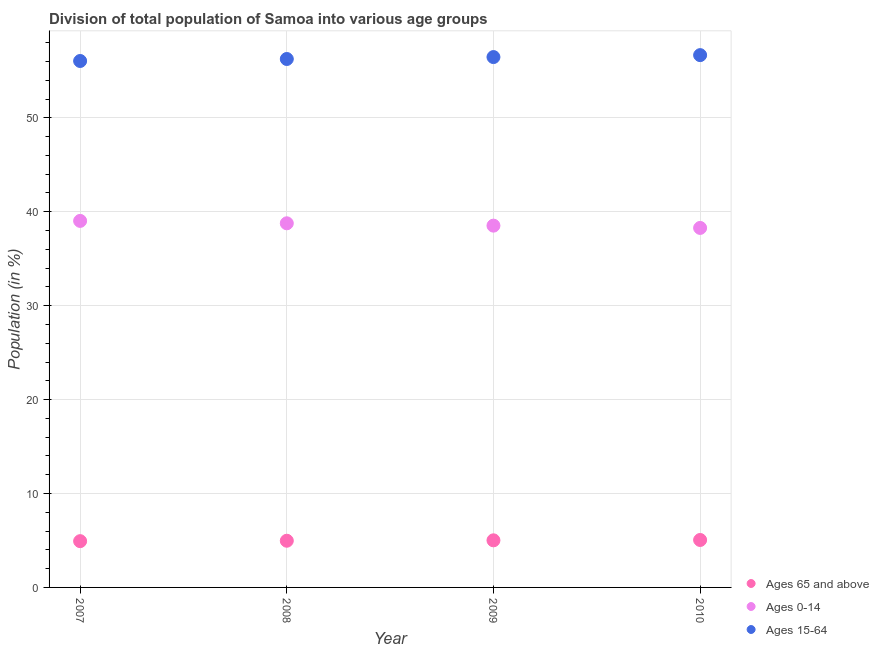How many different coloured dotlines are there?
Your answer should be compact. 3. Is the number of dotlines equal to the number of legend labels?
Keep it short and to the point. Yes. What is the percentage of population within the age-group of 65 and above in 2009?
Offer a terse response. 5.01. Across all years, what is the maximum percentage of population within the age-group 15-64?
Provide a succinct answer. 56.67. Across all years, what is the minimum percentage of population within the age-group of 65 and above?
Keep it short and to the point. 4.93. In which year was the percentage of population within the age-group 15-64 minimum?
Keep it short and to the point. 2007. What is the total percentage of population within the age-group 15-64 in the graph?
Give a very brief answer. 225.45. What is the difference between the percentage of population within the age-group 0-14 in 2008 and that in 2010?
Your answer should be very brief. 0.49. What is the difference between the percentage of population within the age-group of 65 and above in 2007 and the percentage of population within the age-group 0-14 in 2010?
Keep it short and to the point. -33.35. What is the average percentage of population within the age-group of 65 and above per year?
Your response must be concise. 4.99. In the year 2009, what is the difference between the percentage of population within the age-group 15-64 and percentage of population within the age-group 0-14?
Offer a terse response. 17.95. What is the ratio of the percentage of population within the age-group 0-14 in 2007 to that in 2010?
Provide a short and direct response. 1.02. What is the difference between the highest and the second highest percentage of population within the age-group 15-64?
Offer a very short reply. 0.21. What is the difference between the highest and the lowest percentage of population within the age-group 0-14?
Offer a terse response. 0.75. Is the sum of the percentage of population within the age-group of 65 and above in 2007 and 2008 greater than the maximum percentage of population within the age-group 0-14 across all years?
Ensure brevity in your answer.  No. Does the percentage of population within the age-group of 65 and above monotonically increase over the years?
Your response must be concise. Yes. How many dotlines are there?
Provide a short and direct response. 3. How many years are there in the graph?
Keep it short and to the point. 4. Does the graph contain any zero values?
Offer a very short reply. No. Where does the legend appear in the graph?
Provide a short and direct response. Bottom right. How many legend labels are there?
Provide a succinct answer. 3. What is the title of the graph?
Your response must be concise. Division of total population of Samoa into various age groups
. What is the label or title of the X-axis?
Your answer should be compact. Year. What is the Population (in %) of Ages 65 and above in 2007?
Provide a succinct answer. 4.93. What is the Population (in %) of Ages 0-14 in 2007?
Your answer should be very brief. 39.02. What is the Population (in %) in Ages 15-64 in 2007?
Keep it short and to the point. 56.05. What is the Population (in %) of Ages 65 and above in 2008?
Make the answer very short. 4.97. What is the Population (in %) in Ages 0-14 in 2008?
Offer a very short reply. 38.77. What is the Population (in %) of Ages 15-64 in 2008?
Provide a succinct answer. 56.26. What is the Population (in %) of Ages 65 and above in 2009?
Provide a succinct answer. 5.01. What is the Population (in %) in Ages 0-14 in 2009?
Keep it short and to the point. 38.52. What is the Population (in %) in Ages 15-64 in 2009?
Make the answer very short. 56.47. What is the Population (in %) of Ages 65 and above in 2010?
Keep it short and to the point. 5.05. What is the Population (in %) of Ages 0-14 in 2010?
Make the answer very short. 38.28. What is the Population (in %) in Ages 15-64 in 2010?
Provide a succinct answer. 56.67. Across all years, what is the maximum Population (in %) of Ages 65 and above?
Keep it short and to the point. 5.05. Across all years, what is the maximum Population (in %) of Ages 0-14?
Offer a terse response. 39.02. Across all years, what is the maximum Population (in %) in Ages 15-64?
Keep it short and to the point. 56.67. Across all years, what is the minimum Population (in %) of Ages 65 and above?
Offer a very short reply. 4.93. Across all years, what is the minimum Population (in %) in Ages 0-14?
Your answer should be very brief. 38.28. Across all years, what is the minimum Population (in %) in Ages 15-64?
Offer a terse response. 56.05. What is the total Population (in %) in Ages 65 and above in the graph?
Your answer should be very brief. 19.96. What is the total Population (in %) in Ages 0-14 in the graph?
Offer a terse response. 154.59. What is the total Population (in %) of Ages 15-64 in the graph?
Offer a very short reply. 225.45. What is the difference between the Population (in %) in Ages 65 and above in 2007 and that in 2008?
Provide a succinct answer. -0.04. What is the difference between the Population (in %) of Ages 0-14 in 2007 and that in 2008?
Give a very brief answer. 0.26. What is the difference between the Population (in %) of Ages 15-64 in 2007 and that in 2008?
Keep it short and to the point. -0.21. What is the difference between the Population (in %) of Ages 65 and above in 2007 and that in 2009?
Keep it short and to the point. -0.09. What is the difference between the Population (in %) of Ages 0-14 in 2007 and that in 2009?
Your answer should be very brief. 0.51. What is the difference between the Population (in %) in Ages 15-64 in 2007 and that in 2009?
Offer a terse response. -0.42. What is the difference between the Population (in %) of Ages 65 and above in 2007 and that in 2010?
Offer a very short reply. -0.12. What is the difference between the Population (in %) in Ages 0-14 in 2007 and that in 2010?
Ensure brevity in your answer.  0.75. What is the difference between the Population (in %) of Ages 15-64 in 2007 and that in 2010?
Ensure brevity in your answer.  -0.62. What is the difference between the Population (in %) in Ages 65 and above in 2008 and that in 2009?
Provide a succinct answer. -0.04. What is the difference between the Population (in %) in Ages 0-14 in 2008 and that in 2009?
Make the answer very short. 0.25. What is the difference between the Population (in %) in Ages 15-64 in 2008 and that in 2009?
Your answer should be compact. -0.21. What is the difference between the Population (in %) in Ages 65 and above in 2008 and that in 2010?
Provide a short and direct response. -0.08. What is the difference between the Population (in %) in Ages 0-14 in 2008 and that in 2010?
Make the answer very short. 0.49. What is the difference between the Population (in %) in Ages 15-64 in 2008 and that in 2010?
Your answer should be very brief. -0.41. What is the difference between the Population (in %) in Ages 65 and above in 2009 and that in 2010?
Keep it short and to the point. -0.04. What is the difference between the Population (in %) in Ages 0-14 in 2009 and that in 2010?
Provide a succinct answer. 0.24. What is the difference between the Population (in %) in Ages 15-64 in 2009 and that in 2010?
Your answer should be very brief. -0.21. What is the difference between the Population (in %) of Ages 65 and above in 2007 and the Population (in %) of Ages 0-14 in 2008?
Make the answer very short. -33.84. What is the difference between the Population (in %) in Ages 65 and above in 2007 and the Population (in %) in Ages 15-64 in 2008?
Your answer should be very brief. -51.33. What is the difference between the Population (in %) of Ages 0-14 in 2007 and the Population (in %) of Ages 15-64 in 2008?
Offer a very short reply. -17.24. What is the difference between the Population (in %) in Ages 65 and above in 2007 and the Population (in %) in Ages 0-14 in 2009?
Your response must be concise. -33.59. What is the difference between the Population (in %) in Ages 65 and above in 2007 and the Population (in %) in Ages 15-64 in 2009?
Your response must be concise. -51.54. What is the difference between the Population (in %) of Ages 0-14 in 2007 and the Population (in %) of Ages 15-64 in 2009?
Ensure brevity in your answer.  -17.44. What is the difference between the Population (in %) of Ages 65 and above in 2007 and the Population (in %) of Ages 0-14 in 2010?
Ensure brevity in your answer.  -33.35. What is the difference between the Population (in %) of Ages 65 and above in 2007 and the Population (in %) of Ages 15-64 in 2010?
Ensure brevity in your answer.  -51.75. What is the difference between the Population (in %) of Ages 0-14 in 2007 and the Population (in %) of Ages 15-64 in 2010?
Ensure brevity in your answer.  -17.65. What is the difference between the Population (in %) in Ages 65 and above in 2008 and the Population (in %) in Ages 0-14 in 2009?
Give a very brief answer. -33.55. What is the difference between the Population (in %) of Ages 65 and above in 2008 and the Population (in %) of Ages 15-64 in 2009?
Keep it short and to the point. -51.5. What is the difference between the Population (in %) in Ages 0-14 in 2008 and the Population (in %) in Ages 15-64 in 2009?
Ensure brevity in your answer.  -17.7. What is the difference between the Population (in %) in Ages 65 and above in 2008 and the Population (in %) in Ages 0-14 in 2010?
Make the answer very short. -33.3. What is the difference between the Population (in %) in Ages 65 and above in 2008 and the Population (in %) in Ages 15-64 in 2010?
Make the answer very short. -51.7. What is the difference between the Population (in %) in Ages 0-14 in 2008 and the Population (in %) in Ages 15-64 in 2010?
Offer a terse response. -17.91. What is the difference between the Population (in %) in Ages 65 and above in 2009 and the Population (in %) in Ages 0-14 in 2010?
Provide a succinct answer. -33.26. What is the difference between the Population (in %) in Ages 65 and above in 2009 and the Population (in %) in Ages 15-64 in 2010?
Keep it short and to the point. -51.66. What is the difference between the Population (in %) in Ages 0-14 in 2009 and the Population (in %) in Ages 15-64 in 2010?
Ensure brevity in your answer.  -18.15. What is the average Population (in %) in Ages 65 and above per year?
Your response must be concise. 4.99. What is the average Population (in %) of Ages 0-14 per year?
Your response must be concise. 38.65. What is the average Population (in %) in Ages 15-64 per year?
Provide a short and direct response. 56.36. In the year 2007, what is the difference between the Population (in %) of Ages 65 and above and Population (in %) of Ages 0-14?
Your response must be concise. -34.1. In the year 2007, what is the difference between the Population (in %) in Ages 65 and above and Population (in %) in Ages 15-64?
Provide a short and direct response. -51.12. In the year 2007, what is the difference between the Population (in %) in Ages 0-14 and Population (in %) in Ages 15-64?
Your response must be concise. -17.02. In the year 2008, what is the difference between the Population (in %) in Ages 65 and above and Population (in %) in Ages 0-14?
Provide a succinct answer. -33.8. In the year 2008, what is the difference between the Population (in %) of Ages 65 and above and Population (in %) of Ages 15-64?
Make the answer very short. -51.29. In the year 2008, what is the difference between the Population (in %) in Ages 0-14 and Population (in %) in Ages 15-64?
Offer a very short reply. -17.49. In the year 2009, what is the difference between the Population (in %) of Ages 65 and above and Population (in %) of Ages 0-14?
Your answer should be compact. -33.5. In the year 2009, what is the difference between the Population (in %) in Ages 65 and above and Population (in %) in Ages 15-64?
Make the answer very short. -51.45. In the year 2009, what is the difference between the Population (in %) in Ages 0-14 and Population (in %) in Ages 15-64?
Offer a terse response. -17.95. In the year 2010, what is the difference between the Population (in %) in Ages 65 and above and Population (in %) in Ages 0-14?
Ensure brevity in your answer.  -33.22. In the year 2010, what is the difference between the Population (in %) of Ages 65 and above and Population (in %) of Ages 15-64?
Your answer should be compact. -51.62. In the year 2010, what is the difference between the Population (in %) of Ages 0-14 and Population (in %) of Ages 15-64?
Offer a very short reply. -18.4. What is the ratio of the Population (in %) of Ages 65 and above in 2007 to that in 2008?
Your response must be concise. 0.99. What is the ratio of the Population (in %) of Ages 0-14 in 2007 to that in 2008?
Keep it short and to the point. 1.01. What is the ratio of the Population (in %) of Ages 65 and above in 2007 to that in 2009?
Your response must be concise. 0.98. What is the ratio of the Population (in %) in Ages 0-14 in 2007 to that in 2009?
Your answer should be very brief. 1.01. What is the ratio of the Population (in %) of Ages 65 and above in 2007 to that in 2010?
Provide a short and direct response. 0.98. What is the ratio of the Population (in %) of Ages 0-14 in 2007 to that in 2010?
Provide a succinct answer. 1.02. What is the ratio of the Population (in %) of Ages 65 and above in 2008 to that in 2009?
Ensure brevity in your answer.  0.99. What is the ratio of the Population (in %) in Ages 65 and above in 2008 to that in 2010?
Provide a succinct answer. 0.98. What is the ratio of the Population (in %) in Ages 0-14 in 2008 to that in 2010?
Ensure brevity in your answer.  1.01. What is the ratio of the Population (in %) of Ages 15-64 in 2008 to that in 2010?
Provide a succinct answer. 0.99. What is the ratio of the Population (in %) of Ages 0-14 in 2009 to that in 2010?
Provide a succinct answer. 1.01. What is the ratio of the Population (in %) of Ages 15-64 in 2009 to that in 2010?
Your response must be concise. 1. What is the difference between the highest and the second highest Population (in %) of Ages 65 and above?
Keep it short and to the point. 0.04. What is the difference between the highest and the second highest Population (in %) of Ages 0-14?
Give a very brief answer. 0.26. What is the difference between the highest and the second highest Population (in %) of Ages 15-64?
Provide a succinct answer. 0.21. What is the difference between the highest and the lowest Population (in %) in Ages 65 and above?
Offer a very short reply. 0.12. What is the difference between the highest and the lowest Population (in %) in Ages 0-14?
Give a very brief answer. 0.75. What is the difference between the highest and the lowest Population (in %) in Ages 15-64?
Keep it short and to the point. 0.62. 